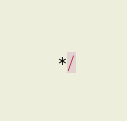Convert code to text. <code><loc_0><loc_0><loc_500><loc_500><_JavaScript_> */</code> 